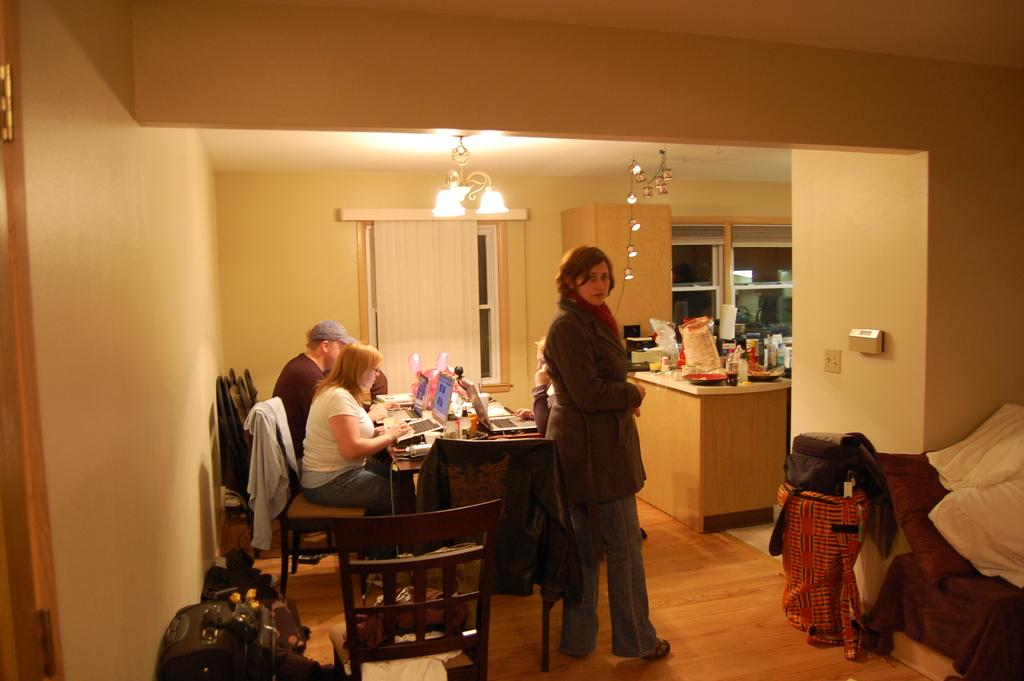What are the people in the image doing? There is a group of persons sitting on the table, and one person is standing near the table. Can you describe the position of the standing person in relation to the table? The person standing is near the table. What can be seen in the background of the image? There are food items visible in the background of the image. What type of account is being discussed by the insect in the image? There is no insect present in the image, and therefore no discussion of an account can be observed. 